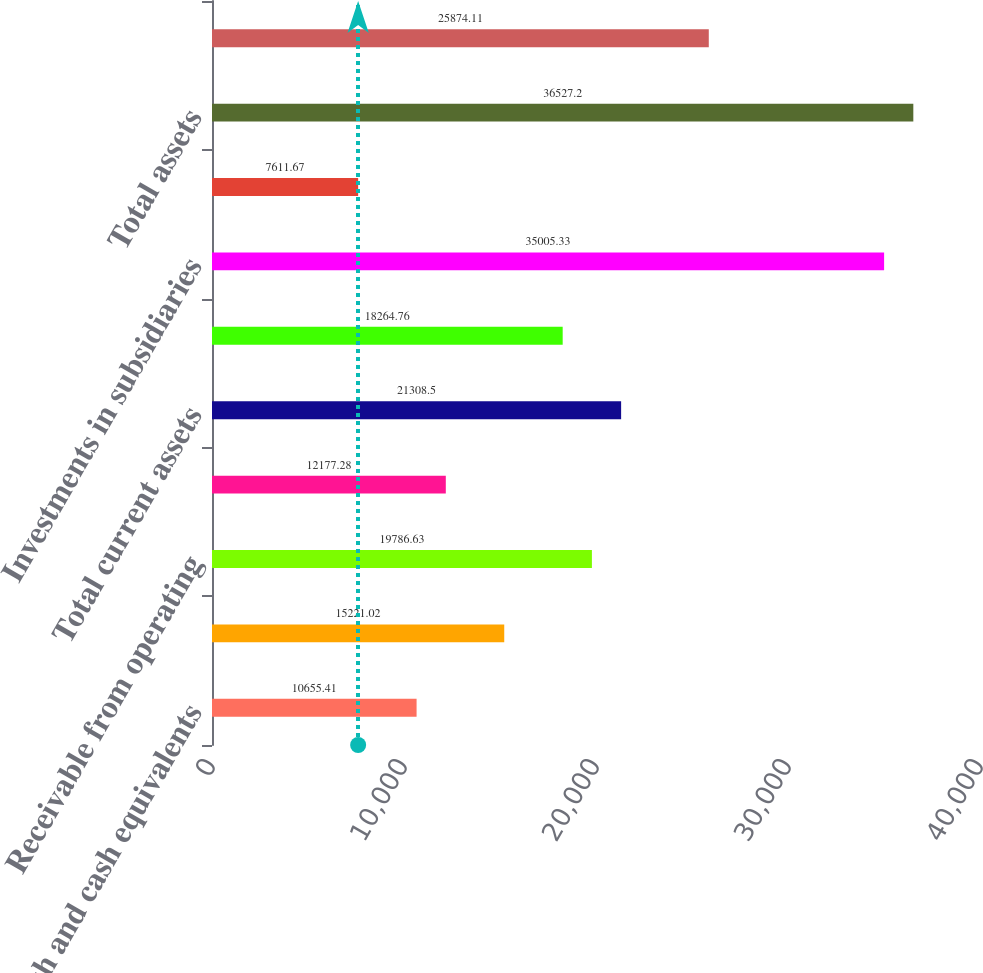Convert chart to OTSL. <chart><loc_0><loc_0><loc_500><loc_500><bar_chart><fcel>Cash and cash equivalents<fcel>Investment securities<fcel>Receivable from operating<fcel>Other current assets<fcel>Total current assets<fcel>Property and equipment net<fcel>Investments in subsidiaries<fcel>Other long-term assets<fcel>Total assets<fcel>Payable to operating<nl><fcel>10655.4<fcel>15221<fcel>19786.6<fcel>12177.3<fcel>21308.5<fcel>18264.8<fcel>35005.3<fcel>7611.67<fcel>36527.2<fcel>25874.1<nl></chart> 